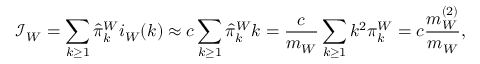Convert formula to latex. <formula><loc_0><loc_0><loc_500><loc_500>\mathcal { I } _ { W } = \sum _ { k \geq 1 } \hat { \pi } _ { k } ^ { W } i _ { W } ( k ) \approx c \sum _ { k \geq 1 } \hat { \pi } _ { k } ^ { W } k = \frac { c } { m _ { W } } \sum _ { k \geq 1 } k ^ { 2 } \pi _ { k } ^ { W } = c \frac { m _ { W } ^ { ( 2 ) } } { m _ { W } } ,</formula> 